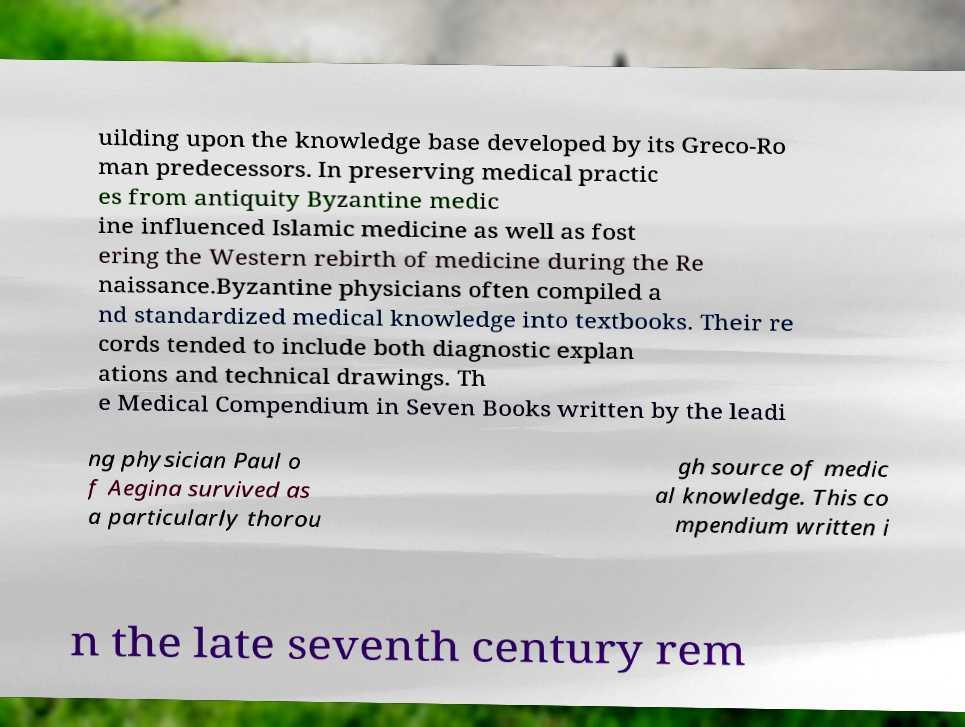Please read and relay the text visible in this image. What does it say? uilding upon the knowledge base developed by its Greco-Ro man predecessors. In preserving medical practic es from antiquity Byzantine medic ine influenced Islamic medicine as well as fost ering the Western rebirth of medicine during the Re naissance.Byzantine physicians often compiled a nd standardized medical knowledge into textbooks. Their re cords tended to include both diagnostic explan ations and technical drawings. Th e Medical Compendium in Seven Books written by the leadi ng physician Paul o f Aegina survived as a particularly thorou gh source of medic al knowledge. This co mpendium written i n the late seventh century rem 